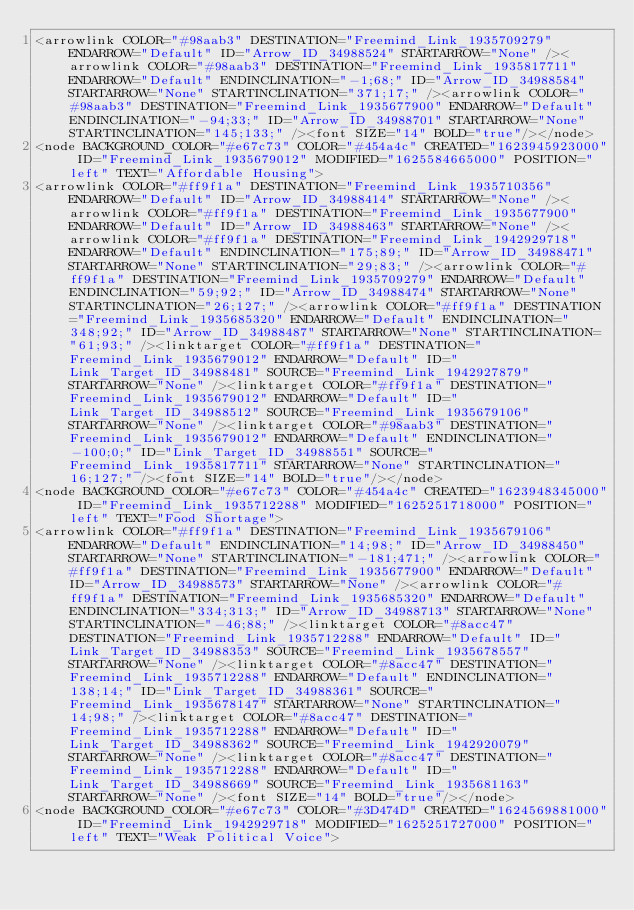<code> <loc_0><loc_0><loc_500><loc_500><_ObjectiveC_><arrowlink COLOR="#98aab3" DESTINATION="Freemind_Link_1935709279" ENDARROW="Default" ID="Arrow_ID_34988524" STARTARROW="None" /><arrowlink COLOR="#98aab3" DESTINATION="Freemind_Link_1935817711" ENDARROW="Default" ENDINCLINATION="-1;68;" ID="Arrow_ID_34988584" STARTARROW="None" STARTINCLINATION="371;17;" /><arrowlink COLOR="#98aab3" DESTINATION="Freemind_Link_1935677900" ENDARROW="Default" ENDINCLINATION="-94;33;" ID="Arrow_ID_34988701" STARTARROW="None" STARTINCLINATION="145;133;" /><font SIZE="14" BOLD="true"/></node>
<node BACKGROUND_COLOR="#e67c73" COLOR="#454a4c" CREATED="1623945923000" ID="Freemind_Link_1935679012" MODIFIED="1625584665000" POSITION="left" TEXT="Affordable Housing">
<arrowlink COLOR="#ff9f1a" DESTINATION="Freemind_Link_1935710356" ENDARROW="Default" ID="Arrow_ID_34988414" STARTARROW="None" /><arrowlink COLOR="#ff9f1a" DESTINATION="Freemind_Link_1935677900" ENDARROW="Default" ID="Arrow_ID_34988463" STARTARROW="None" /><arrowlink COLOR="#ff9f1a" DESTINATION="Freemind_Link_1942929718" ENDARROW="Default" ENDINCLINATION="175;89;" ID="Arrow_ID_34988471" STARTARROW="None" STARTINCLINATION="29;83;" /><arrowlink COLOR="#ff9f1a" DESTINATION="Freemind_Link_1935709279" ENDARROW="Default" ENDINCLINATION="59;92;" ID="Arrow_ID_34988474" STARTARROW="None" STARTINCLINATION="26;127;" /><arrowlink COLOR="#ff9f1a" DESTINATION="Freemind_Link_1935685320" ENDARROW="Default" ENDINCLINATION="348;92;" ID="Arrow_ID_34988487" STARTARROW="None" STARTINCLINATION="61;93;" /><linktarget COLOR="#ff9f1a" DESTINATION="Freemind_Link_1935679012" ENDARROW="Default" ID="Link_Target_ID_34988481" SOURCE="Freemind_Link_1942927879" STARTARROW="None" /><linktarget COLOR="#ff9f1a" DESTINATION="Freemind_Link_1935679012" ENDARROW="Default" ID="Link_Target_ID_34988512" SOURCE="Freemind_Link_1935679106" STARTARROW="None" /><linktarget COLOR="#98aab3" DESTINATION="Freemind_Link_1935679012" ENDARROW="Default" ENDINCLINATION="-100;0;" ID="Link_Target_ID_34988551" SOURCE="Freemind_Link_1935817711" STARTARROW="None" STARTINCLINATION="16;127;" /><font SIZE="14" BOLD="true"/></node>
<node BACKGROUND_COLOR="#e67c73" COLOR="#454a4c" CREATED="1623948345000" ID="Freemind_Link_1935712288" MODIFIED="1625251718000" POSITION="left" TEXT="Food Shortage">
<arrowlink COLOR="#ff9f1a" DESTINATION="Freemind_Link_1935679106" ENDARROW="Default" ENDINCLINATION="14;98;" ID="Arrow_ID_34988450" STARTARROW="None" STARTINCLINATION="-181;471;" /><arrowlink COLOR="#ff9f1a" DESTINATION="Freemind_Link_1935677900" ENDARROW="Default" ID="Arrow_ID_34988573" STARTARROW="None" /><arrowlink COLOR="#ff9f1a" DESTINATION="Freemind_Link_1935685320" ENDARROW="Default" ENDINCLINATION="334;313;" ID="Arrow_ID_34988713" STARTARROW="None" STARTINCLINATION="-46;88;" /><linktarget COLOR="#8acc47" DESTINATION="Freemind_Link_1935712288" ENDARROW="Default" ID="Link_Target_ID_34988353" SOURCE="Freemind_Link_1935678557" STARTARROW="None" /><linktarget COLOR="#8acc47" DESTINATION="Freemind_Link_1935712288" ENDARROW="Default" ENDINCLINATION="138;14;" ID="Link_Target_ID_34988361" SOURCE="Freemind_Link_1935678147" STARTARROW="None" STARTINCLINATION="14;98;" /><linktarget COLOR="#8acc47" DESTINATION="Freemind_Link_1935712288" ENDARROW="Default" ID="Link_Target_ID_34988362" SOURCE="Freemind_Link_1942920079" STARTARROW="None" /><linktarget COLOR="#8acc47" DESTINATION="Freemind_Link_1935712288" ENDARROW="Default" ID="Link_Target_ID_34988669" SOURCE="Freemind_Link_1935681163" STARTARROW="None" /><font SIZE="14" BOLD="true"/></node>
<node BACKGROUND_COLOR="#e67c73" COLOR="#3D474D" CREATED="1624569881000" ID="Freemind_Link_1942929718" MODIFIED="1625251727000" POSITION="left" TEXT="Weak Political Voice"></code> 